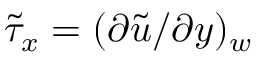<formula> <loc_0><loc_0><loc_500><loc_500>\tilde { \tau } _ { x } = ( \partial \tilde { u } / \partial y ) _ { w }</formula> 